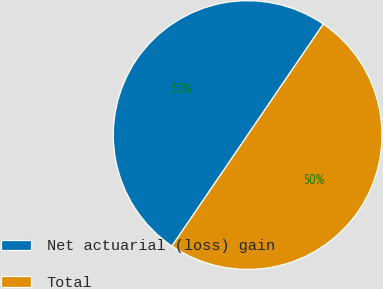<chart> <loc_0><loc_0><loc_500><loc_500><pie_chart><fcel>Net actuarial (loss) gain<fcel>Total<nl><fcel>50.0%<fcel>50.0%<nl></chart> 